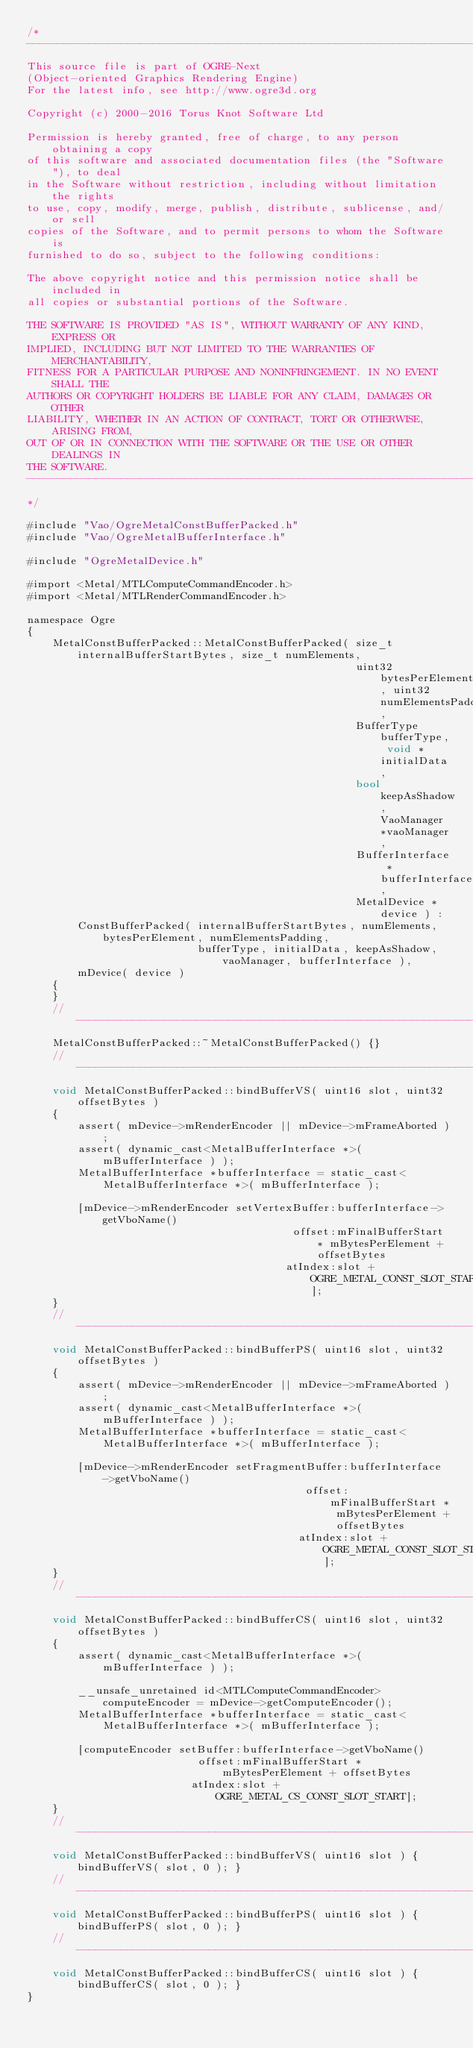<code> <loc_0><loc_0><loc_500><loc_500><_ObjectiveC_>/*
-----------------------------------------------------------------------------
This source file is part of OGRE-Next
(Object-oriented Graphics Rendering Engine)
For the latest info, see http://www.ogre3d.org

Copyright (c) 2000-2016 Torus Knot Software Ltd

Permission is hereby granted, free of charge, to any person obtaining a copy
of this software and associated documentation files (the "Software"), to deal
in the Software without restriction, including without limitation the rights
to use, copy, modify, merge, publish, distribute, sublicense, and/or sell
copies of the Software, and to permit persons to whom the Software is
furnished to do so, subject to the following conditions:

The above copyright notice and this permission notice shall be included in
all copies or substantial portions of the Software.

THE SOFTWARE IS PROVIDED "AS IS", WITHOUT WARRANTY OF ANY KIND, EXPRESS OR
IMPLIED, INCLUDING BUT NOT LIMITED TO THE WARRANTIES OF MERCHANTABILITY,
FITNESS FOR A PARTICULAR PURPOSE AND NONINFRINGEMENT. IN NO EVENT SHALL THE
AUTHORS OR COPYRIGHT HOLDERS BE LIABLE FOR ANY CLAIM, DAMAGES OR OTHER
LIABILITY, WHETHER IN AN ACTION OF CONTRACT, TORT OR OTHERWISE, ARISING FROM,
OUT OF OR IN CONNECTION WITH THE SOFTWARE OR THE USE OR OTHER DEALINGS IN
THE SOFTWARE.
-----------------------------------------------------------------------------
*/

#include "Vao/OgreMetalConstBufferPacked.h"
#include "Vao/OgreMetalBufferInterface.h"

#include "OgreMetalDevice.h"

#import <Metal/MTLComputeCommandEncoder.h>
#import <Metal/MTLRenderCommandEncoder.h>

namespace Ogre
{
    MetalConstBufferPacked::MetalConstBufferPacked( size_t internalBufferStartBytes, size_t numElements,
                                                    uint32 bytesPerElement, uint32 numElementsPadding,
                                                    BufferType bufferType, void *initialData,
                                                    bool keepAsShadow, VaoManager *vaoManager,
                                                    BufferInterface *bufferInterface,
                                                    MetalDevice *device ) :
        ConstBufferPacked( internalBufferStartBytes, numElements, bytesPerElement, numElementsPadding,
                           bufferType, initialData, keepAsShadow, vaoManager, bufferInterface ),
        mDevice( device )
    {
    }
    //-----------------------------------------------------------------------------------
    MetalConstBufferPacked::~MetalConstBufferPacked() {}
    //-----------------------------------------------------------------------------------
    void MetalConstBufferPacked::bindBufferVS( uint16 slot, uint32 offsetBytes )
    {
        assert( mDevice->mRenderEncoder || mDevice->mFrameAborted );
        assert( dynamic_cast<MetalBufferInterface *>( mBufferInterface ) );
        MetalBufferInterface *bufferInterface = static_cast<MetalBufferInterface *>( mBufferInterface );

        [mDevice->mRenderEncoder setVertexBuffer:bufferInterface->getVboName()
                                          offset:mFinalBufferStart * mBytesPerElement + offsetBytes
                                         atIndex:slot + OGRE_METAL_CONST_SLOT_START];
    }
    //-----------------------------------------------------------------------------------
    void MetalConstBufferPacked::bindBufferPS( uint16 slot, uint32 offsetBytes )
    {
        assert( mDevice->mRenderEncoder || mDevice->mFrameAborted );
        assert( dynamic_cast<MetalBufferInterface *>( mBufferInterface ) );
        MetalBufferInterface *bufferInterface = static_cast<MetalBufferInterface *>( mBufferInterface );

        [mDevice->mRenderEncoder setFragmentBuffer:bufferInterface->getVboName()
                                            offset:mFinalBufferStart * mBytesPerElement + offsetBytes
                                           atIndex:slot + OGRE_METAL_CONST_SLOT_START];
    }
    //-----------------------------------------------------------------------------------
    void MetalConstBufferPacked::bindBufferCS( uint16 slot, uint32 offsetBytes )
    {
        assert( dynamic_cast<MetalBufferInterface *>( mBufferInterface ) );

        __unsafe_unretained id<MTLComputeCommandEncoder> computeEncoder = mDevice->getComputeEncoder();
        MetalBufferInterface *bufferInterface = static_cast<MetalBufferInterface *>( mBufferInterface );

        [computeEncoder setBuffer:bufferInterface->getVboName()
                           offset:mFinalBufferStart * mBytesPerElement + offsetBytes
                          atIndex:slot + OGRE_METAL_CS_CONST_SLOT_START];
    }
    //-----------------------------------------------------------------------------------
    void MetalConstBufferPacked::bindBufferVS( uint16 slot ) { bindBufferVS( slot, 0 ); }
    //-----------------------------------------------------------------------------------
    void MetalConstBufferPacked::bindBufferPS( uint16 slot ) { bindBufferPS( slot, 0 ); }
    //-----------------------------------------------------------------------------------
    void MetalConstBufferPacked::bindBufferCS( uint16 slot ) { bindBufferCS( slot, 0 ); }
}
</code> 